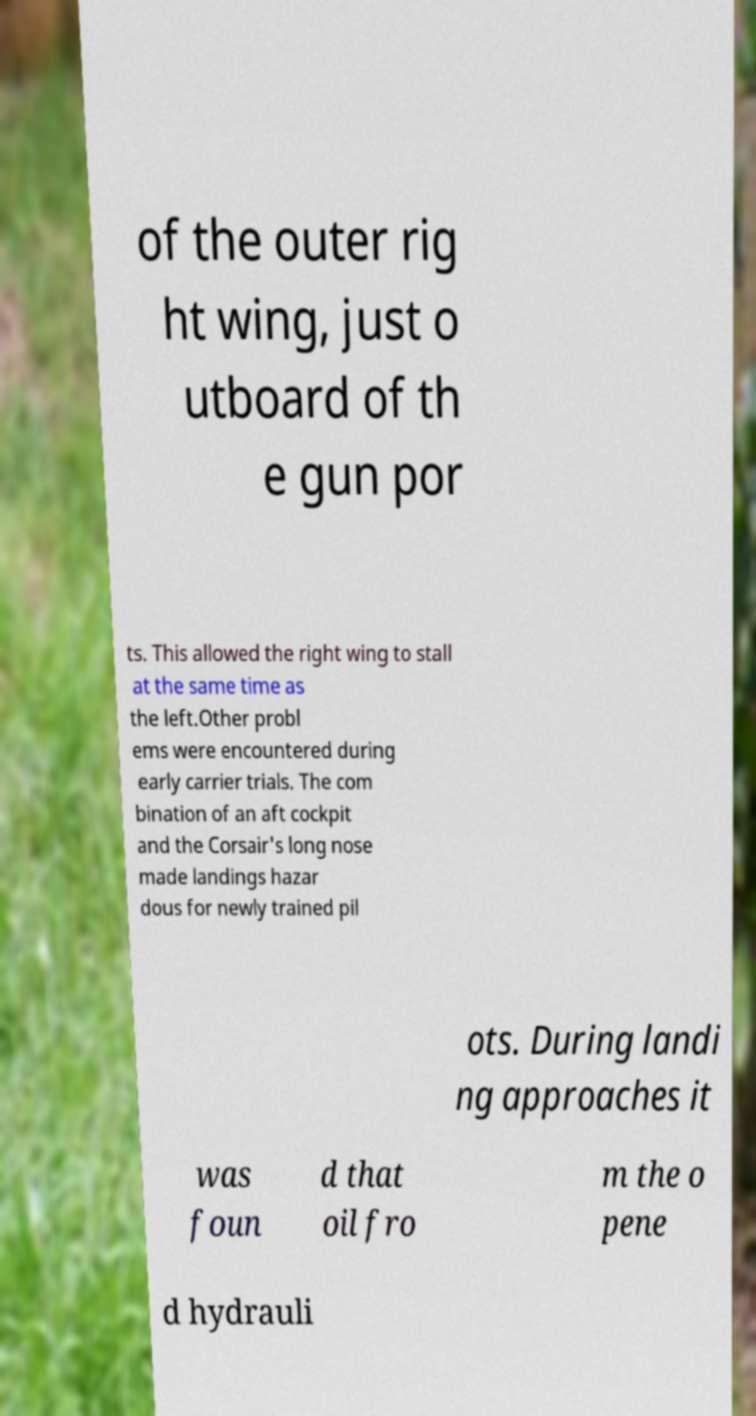Can you accurately transcribe the text from the provided image for me? of the outer rig ht wing, just o utboard of th e gun por ts. This allowed the right wing to stall at the same time as the left.Other probl ems were encountered during early carrier trials. The com bination of an aft cockpit and the Corsair's long nose made landings hazar dous for newly trained pil ots. During landi ng approaches it was foun d that oil fro m the o pene d hydrauli 